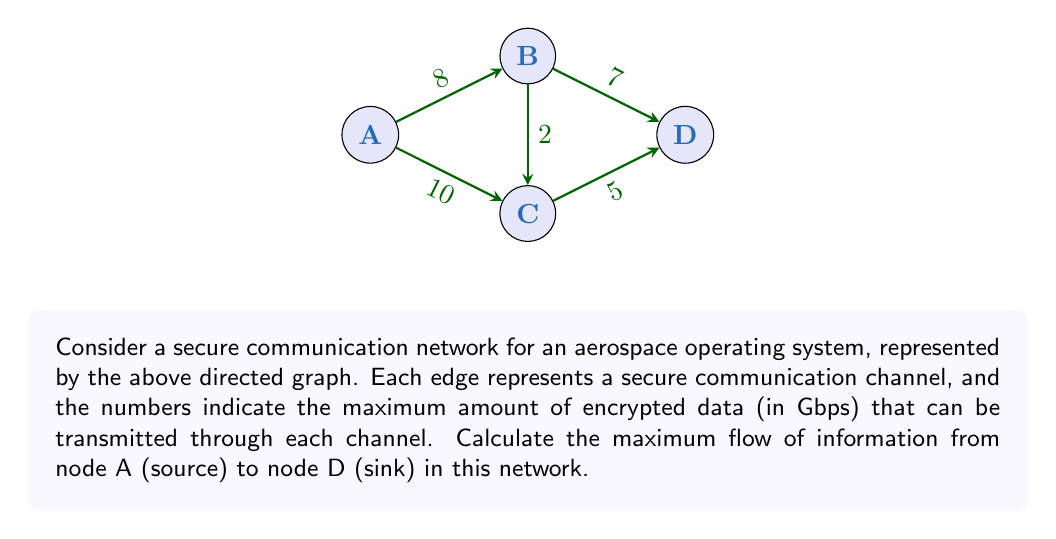Provide a solution to this math problem. To solve this problem, we'll use the Ford-Fulkerson algorithm to find the maximum flow in the network.

Step 1: Initialize the flow to 0 for all edges.

Step 2: Find an augmenting path from A to D. We'll use depth-first search (DFS).
Path 1: A → B → D (min capacity = 7)
Update flow:
A → B: 7/8
B → D: 7/7

Step 3: Find another augmenting path.
Path 2: A → C → D (min capacity = 5)
Update flow:
A → C: 5/10
C → D: 5/5

Step 4: Find another augmenting path.
Path 3: A → B → C → D (min capacity = 1)
Update flow:
A → B: 8/8
B → C: 1/2
C → D: 5/5 (no change)

Step 5: No more augmenting paths exist, so we've found the maximum flow.

The maximum flow is the sum of the flows on all paths from A to D:
$$\text{Max Flow} = 7 + 5 + 1 = 13 \text{ Gbps}$$

This result means that the secure communication network can transmit a maximum of 13 Gbps of encrypted data from the source (A) to the sink (D) simultaneously.
Answer: 13 Gbps 